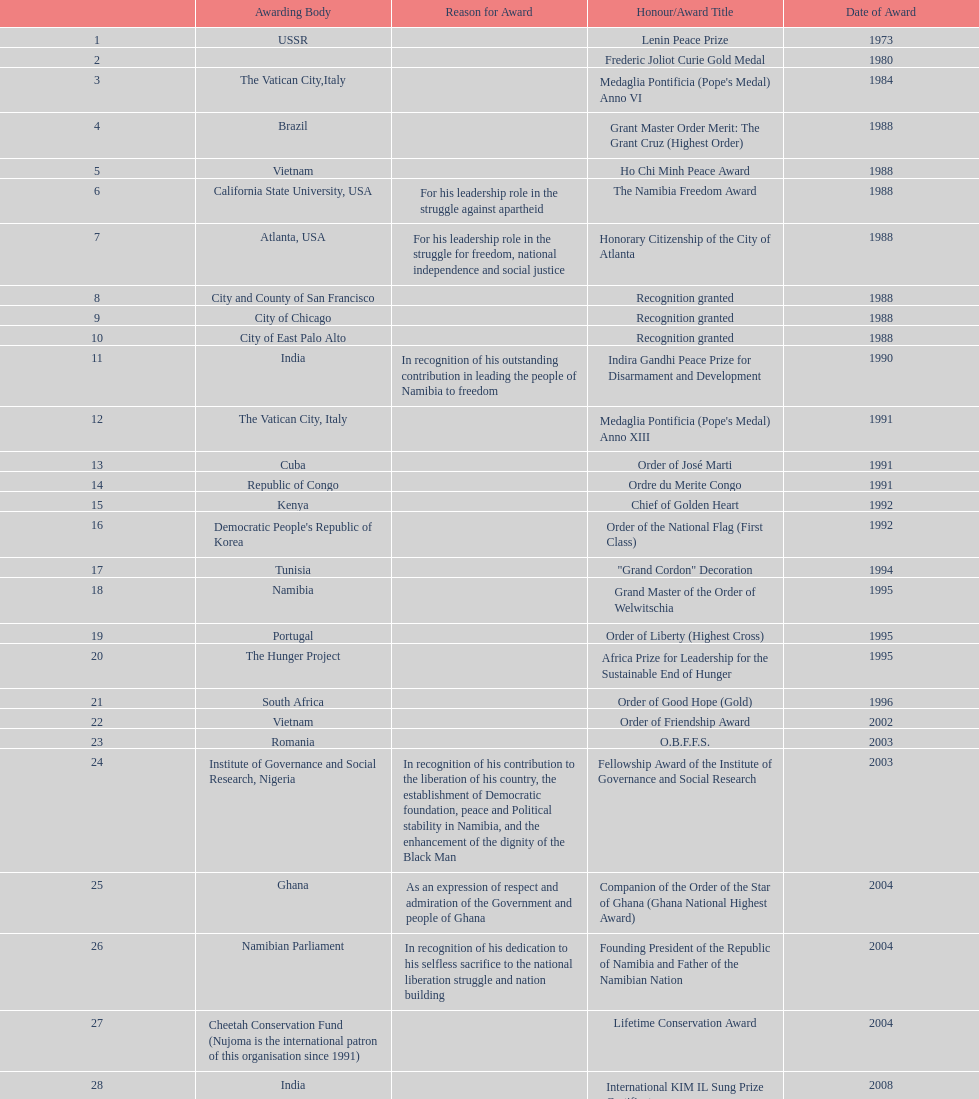What was the last award that nujoma won? Sir Seretse Khama SADC Meda. 